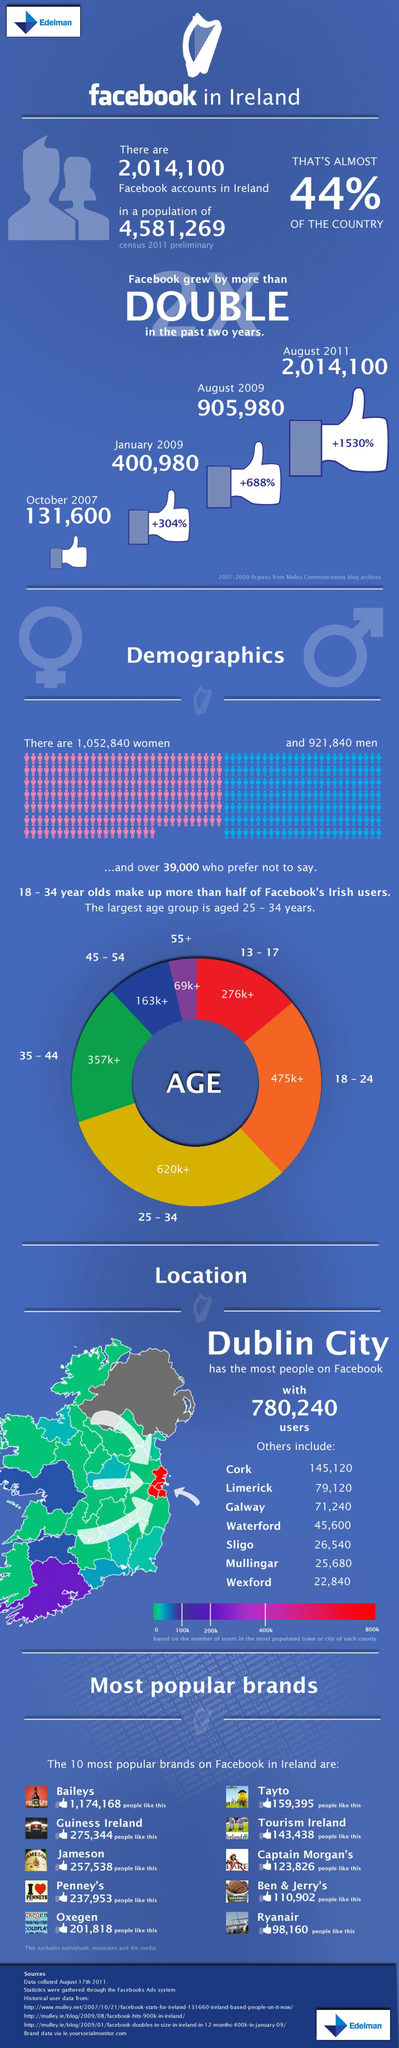Identify some key points in this picture. The age group denoted by the color orange is 18-24. Women have the majority of users. It is estimated that approximately 620,000+ individuals make up the 25-34 age group. In August 2011, Facebook experienced a significant increase in growth, with a percentage increase of +1530%. It is estimated that over 69,000 senior citizens use Facebook. 